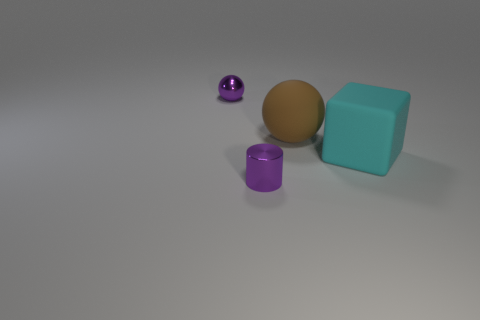Are there any small metal objects that have the same color as the tiny metallic sphere?
Give a very brief answer. Yes. Is the small metallic ball the same color as the small cylinder?
Your answer should be compact. Yes. How many spheres have the same color as the small metallic cylinder?
Provide a succinct answer. 1. There is another shiny thing that is the same shape as the large brown object; what size is it?
Keep it short and to the point. Small. The object that is both in front of the big brown sphere and left of the large cyan rubber cube is what color?
Provide a short and direct response. Purple. Are the brown object and the purple object that is behind the big block made of the same material?
Keep it short and to the point. No. Is the number of small purple spheres in front of the cylinder less than the number of tiny spheres?
Ensure brevity in your answer.  Yes. What number of other objects are there of the same shape as the cyan thing?
Provide a short and direct response. 0. Is there any other thing of the same color as the big rubber cube?
Offer a terse response. No. Do the big cube and the sphere that is to the left of the tiny purple cylinder have the same color?
Offer a very short reply. No. 